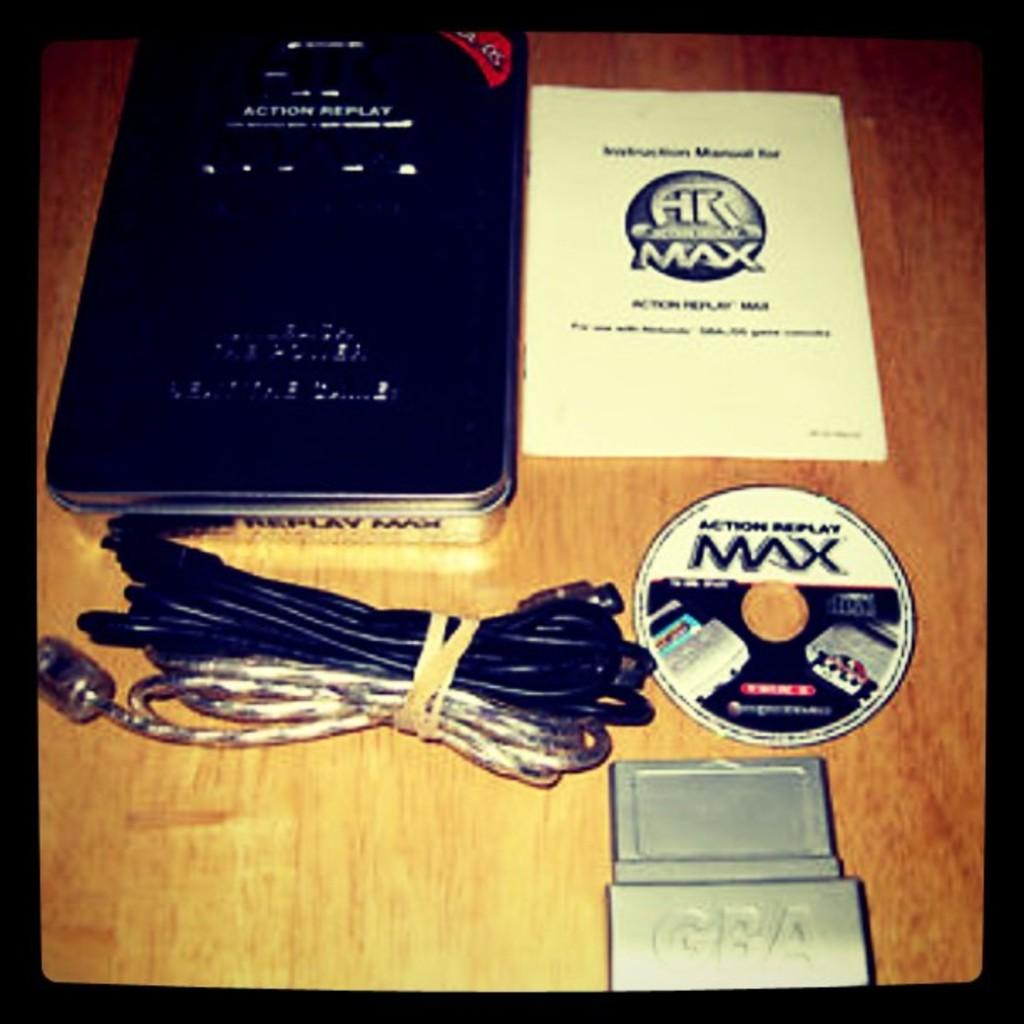<image>
Summarize the visual content of the image. A "Max" brand CD with case and cords. 